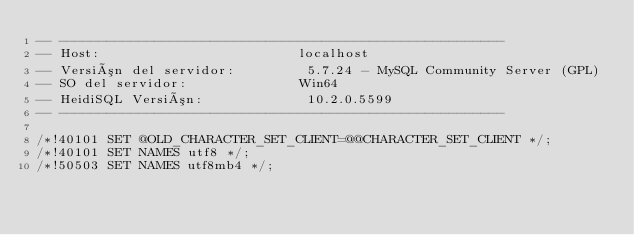<code> <loc_0><loc_0><loc_500><loc_500><_SQL_>-- --------------------------------------------------------
-- Host:                         localhost
-- Versión del servidor:         5.7.24 - MySQL Community Server (GPL)
-- SO del servidor:              Win64
-- HeidiSQL Versión:             10.2.0.5599
-- --------------------------------------------------------

/*!40101 SET @OLD_CHARACTER_SET_CLIENT=@@CHARACTER_SET_CLIENT */;
/*!40101 SET NAMES utf8 */;
/*!50503 SET NAMES utf8mb4 */;</code> 